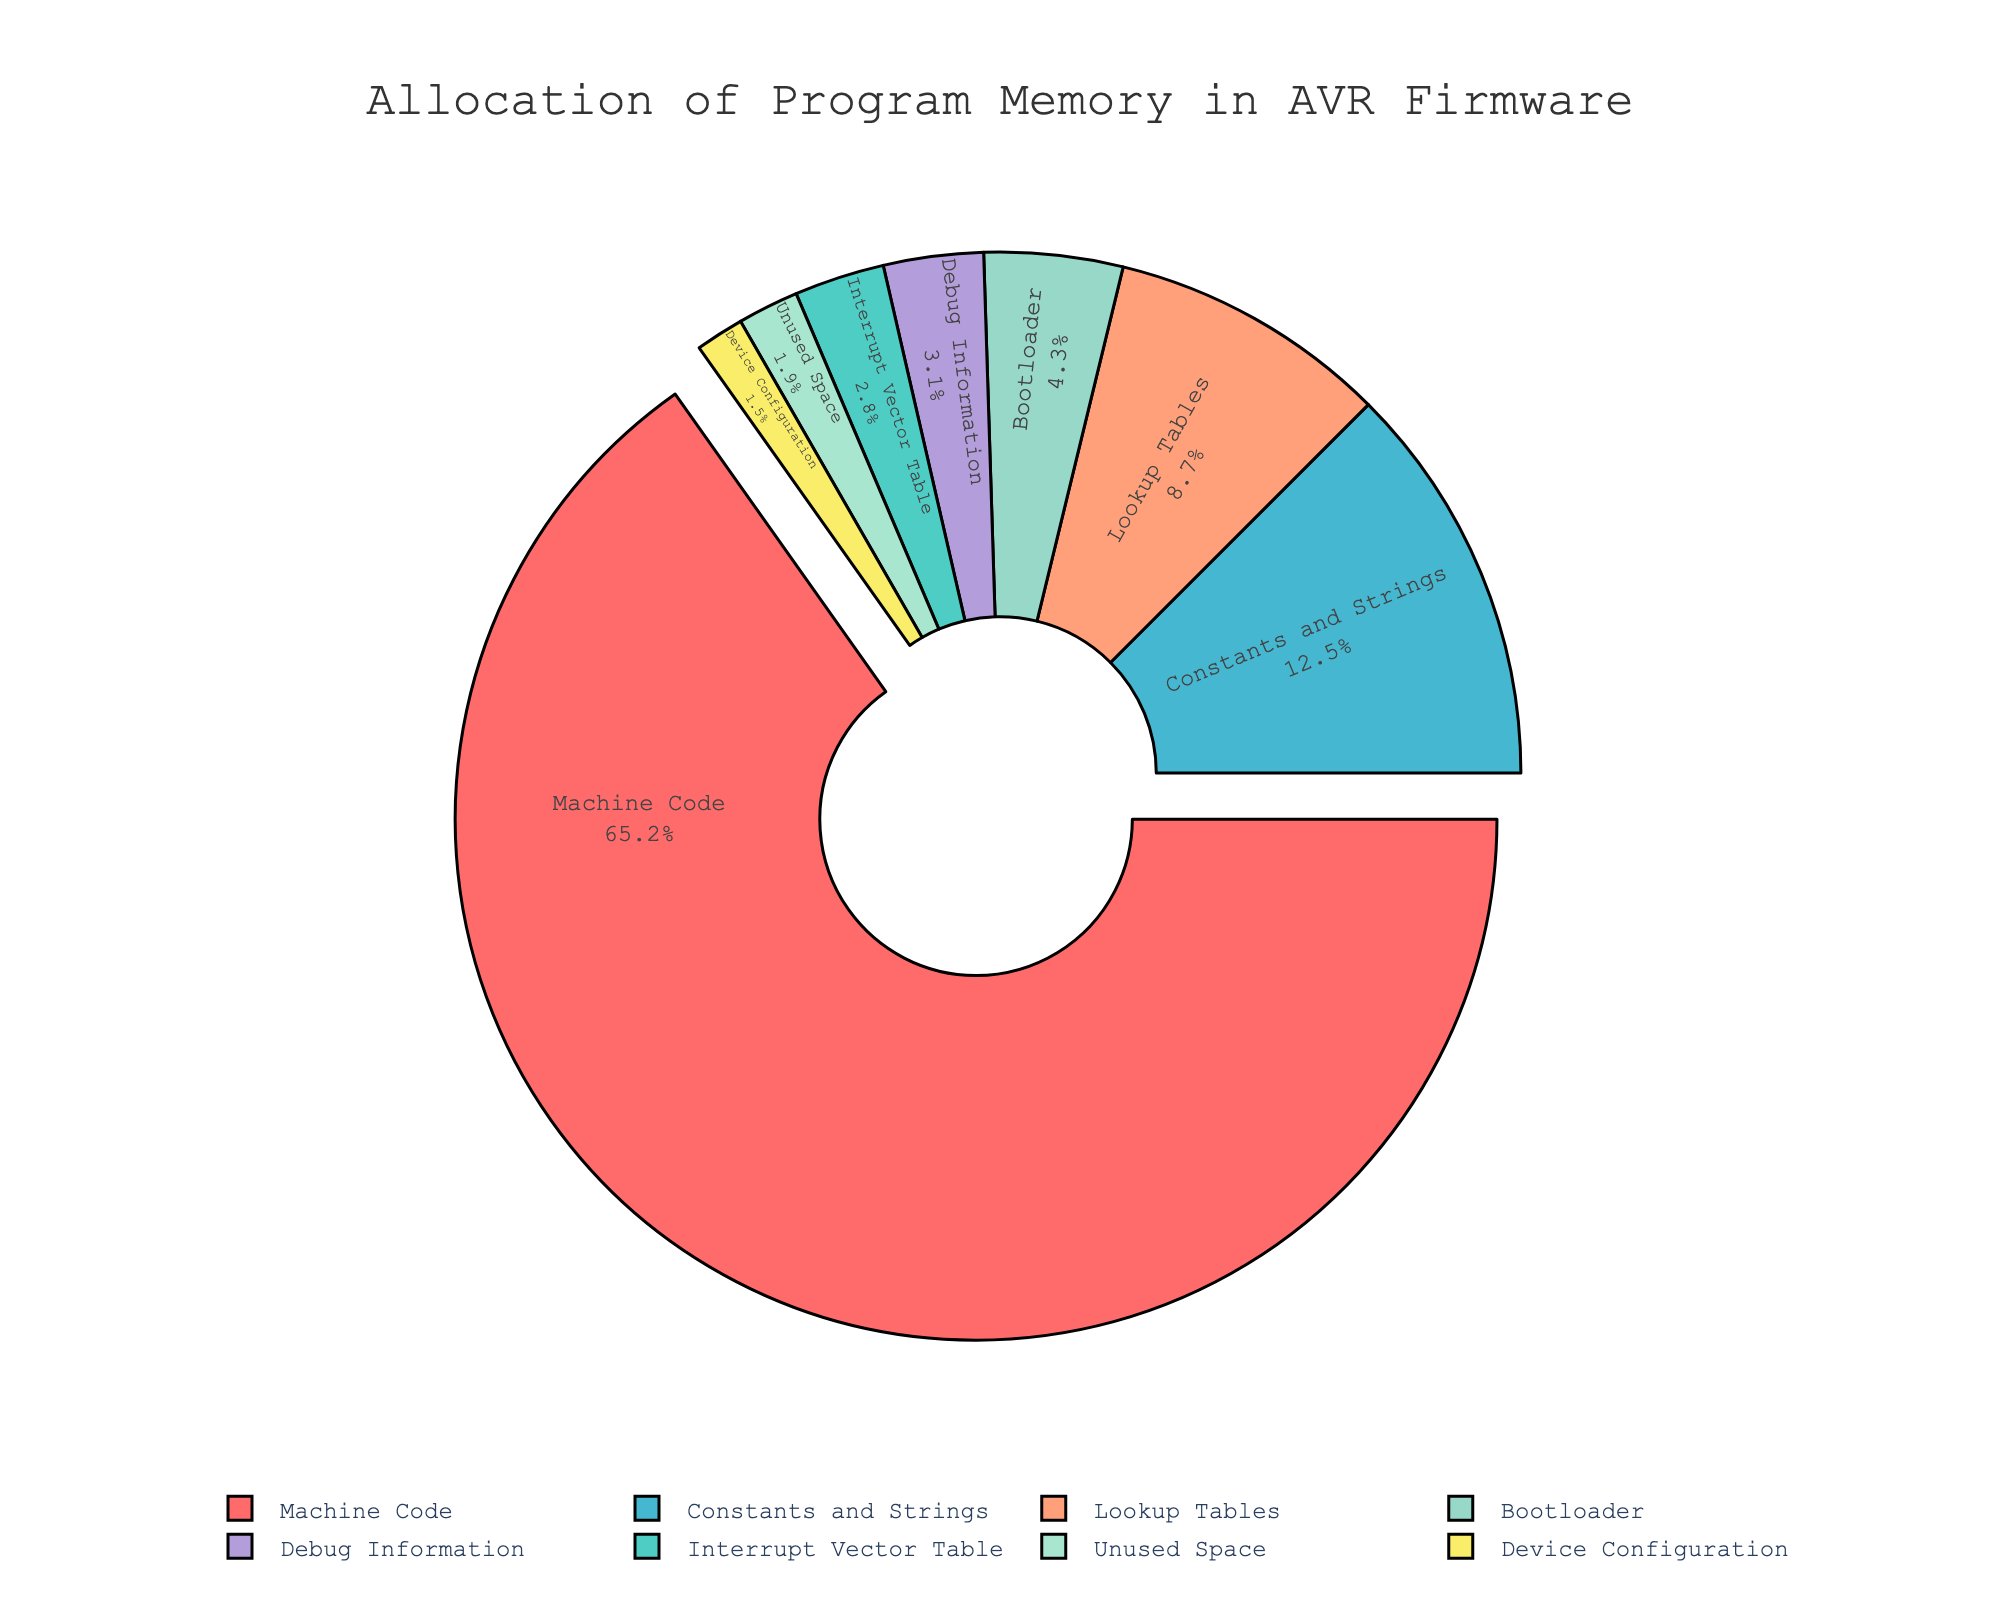What percentage of the program memory is occupied by constants and strings? Look at the slice representing "Constants and Strings". It is labeled with its percentage.
Answer: 12.5% Which category has the smallest allocation of program memory? Compare the percentages for all categories and identify the smallest one. The slice for "Device Configuration" is the smallest.
Answer: Device Configuration How much more program memory is used for lookup tables than for the bootloader? Subtract the percentage for "Bootloader" from the percentage for "Lookup Tables". 8.7 - 4.3 = 4.4%.
Answer: 4.4% What two categories together make up approximately 15% of the program memory? Add the percentages of different categories until reaching about 15%. "Interrupt Vector Table" (2.8%) and "Debug Information" (3.1%) together make 5.9%. For another combination, "Unused Space" (1.9%) and "Device Configuration" (1.5%) together make up 3.4%. Perhaps ''Bootloader'' (4.3%) and Device configuration (1.5%) together make 5.8%.
Answer: Interrupt Vector Table + Debug Information, Bootloader + Device Configuration If you combine the memory allocated to machine code and unused space, what percentage of memory allocation does this represent? Add the percentages for "Machine Code" and "Unused Space". 65.2 + 1.9 = 67.1%.
Answer: 67.1% Which category occupies a similar amount of memory as the sum of constants and strings, and device configuration? Find the sum of "Constants and Strings" (12.5%) and "Device Configuration" (1.5%), which gives 12.5+1.5=14%. Compare this total with other categories. The closest is "Lookup Tables" with 8.7%. Constant Strings and Debug Information make a closer match with 15.6
Answer: Debug Information + String Constants What is the difference in percentage between the largest and the smallest memory allocations? Subtract the smallest percentage (Device Configuration: 1.5%) from the largest percentage (Machine Code: 65.2%). 65.2 - 1.5 = 63.7%.
Answer: 63.7% Which category is displayed in the green slice? Observe the color associated with each category; the green slice represents "Interrupt Vector Table".
Answer: Interrupt Vector Table What percentage of the memory is allocated to debugging information? Look at the slice labeled "Debug Information" and note its percentage.
Answer: 3.1% Compare the memory allocation between bootloader and unused space. Which category has a higher percentage, and by how much? Subtract the percentage of "Unused Space" from that of "Bootloader". 4.3 - 1.9 = 2.4%.
Answer: Bootloader by 2.4% 